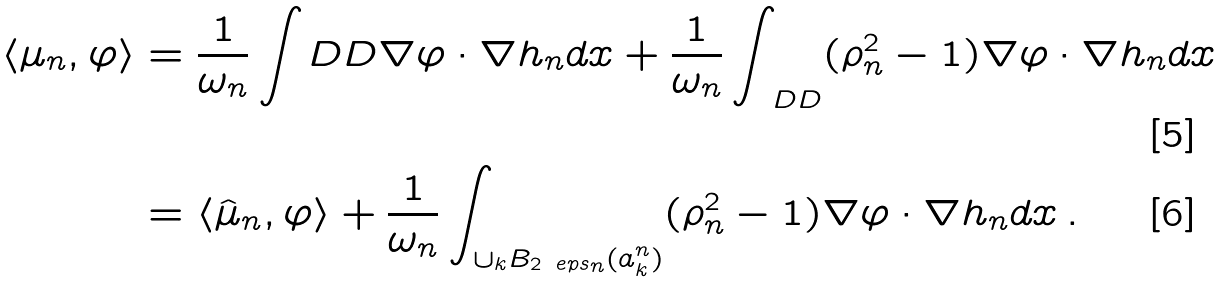<formula> <loc_0><loc_0><loc_500><loc_500>\langle \mu _ { n } , \varphi \rangle & = \frac { 1 } { \omega _ { n } } \int _ { \ } D D \nabla \varphi \cdot \nabla h _ { n } d x + \frac { 1 } { \omega _ { n } } \int _ { \ D D } ( \rho _ { n } ^ { 2 } - 1 ) \nabla \varphi \cdot \nabla h _ { n } d x \\ & = \langle \hat { \mu } _ { n } , \varphi \rangle + \frac { 1 } { \omega _ { n } } \int _ { \cup _ { k } B _ { 2 \ e p s _ { n } } ( a _ { k } ^ { n } ) } ( \rho _ { n } ^ { 2 } - 1 ) \nabla \varphi \cdot \nabla h _ { n } d x \, .</formula> 